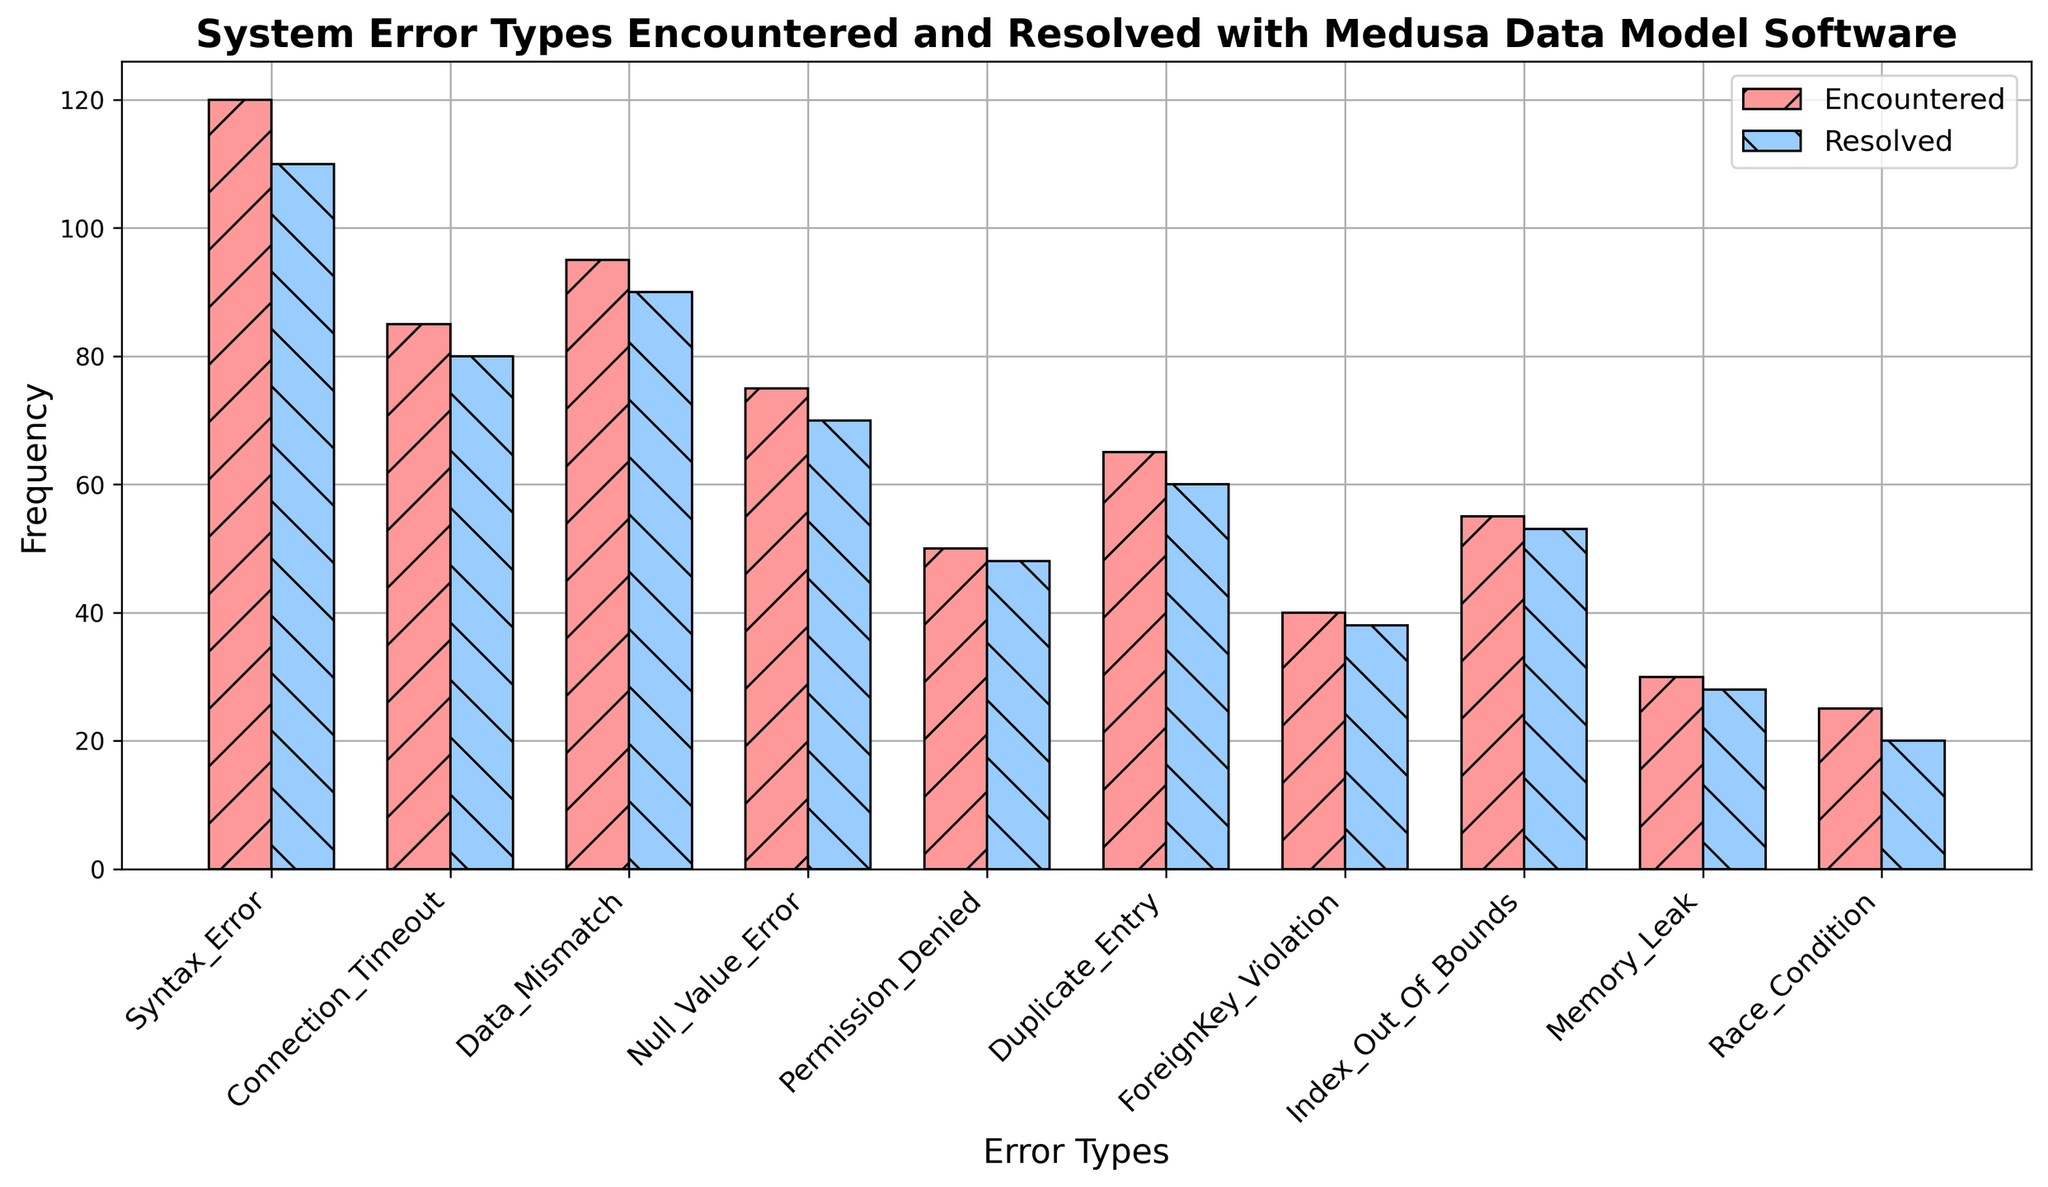What's the total number of System Errors Encountered? Sum the frequencies of all error types in the "Encountered" category: 120 + 85 + 95 + 75 + 50 + 65 + 40 + 55 + 30 + 25 = 640
Answer: 640 Which type of error was Encountered the most frequently? The bar representing "Syntax Error" is the highest among the Encountered errors, indicating it has the highest frequency.
Answer: Syntax Error How many more times was a Syntax Error Encountered compared to a Memory Leak? Subtract the frequency of Memory Leak encountered from the frequency of Syntax Error encountered: 120 - 30 = 90
Answer: 90 Which error type has the closest Encountered frequency to a Null Value Error? The frequency of Null Value Error encountered is 75. The closest Encountered frequencies are those of Index Out Of Bounds (55) and Permission Denied (50), but Data Mismatch (95) is the nearest.
Answer: Data Mismatch Out of the errors listed, which one has the smallest difference between the Encountered and Resolved frequencies? Calculate the differences for each error type and find the smallest: Syntax Error (10), Connection Timeout (5), Data Mismatch (5), Null Value Error (5), Permission Denied (2), Duplicate Entry (5), ForeignKey Violation (2), Index Out Of Bounds (2), Memory Leak (2), Race Condition (5). The smallest differences are 2, shared by Permission Denied, ForeignKey Violation, Index Out Of Bounds, and Memory Leak.
Answer: Permission Denied How much higher is the total number of Resolved Errors compared to the total number of Unresolved Errors? First, calculate the total Resolved errors: 110 + 80 + 90 + 70 + 48 + 60 + 38 + 53 + 28 + 20 = 597. Then, calculate the total Encountered errors: 640. Finally, subtract the total Resolved from the total Encountered to find Unresolved: 640 - 597 = 43. Hence, the difference is 597 - 43 = 554.
Answer: 554 Which error types have a Resolved frequency that is less than their Encountered frequency? Check each error type and see if the Resolved frequency is less than the Encountered frequency. All the types meet this criterion.
Answer: All Among the listed errors, which one is the least Resolved? The bar for "least Resolved" error is the shortest among resolves. The bar for "Race Condition" is the shortest, indicating it is the least resolved.
Answer: Race Condition Which error type has a greater Resolved frequency than Null Value Error's Resolved frequency? Null Value Error's Resolved frequency is 70. Compare it with other Resolved frequencies: Syntax Error (110), Connection Timeout (80), Data Mismatch (90), Duplicate Entry (60), ForeignKey Violation (38), Index Out Of Bounds (53), Memory Leak (28), Race Condition (20). Only Syntax Error, Connection Timeout, and Data Mismatch have greater Resolved frequencies.
Answer: Syntax Error, Connection Timeout, Data Mismatch 